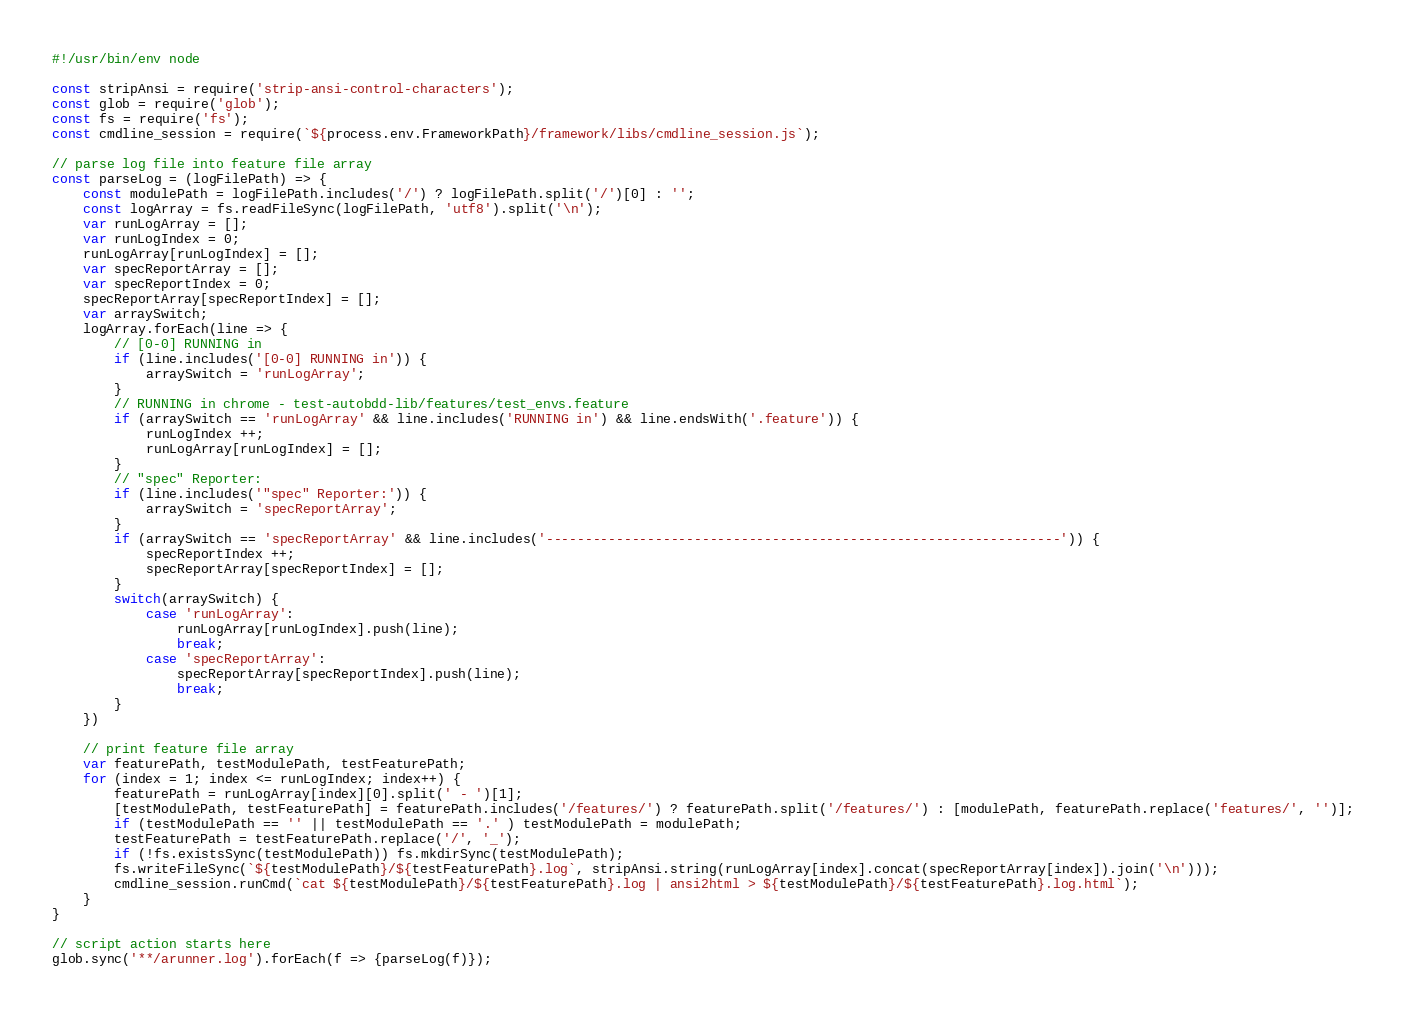Convert code to text. <code><loc_0><loc_0><loc_500><loc_500><_JavaScript_>#!/usr/bin/env node

const stripAnsi = require('strip-ansi-control-characters');
const glob = require('glob');
const fs = require('fs');
const cmdline_session = require(`${process.env.FrameworkPath}/framework/libs/cmdline_session.js`);

// parse log file into feature file array
const parseLog = (logFilePath) => {
    const modulePath = logFilePath.includes('/') ? logFilePath.split('/')[0] : '';
    const logArray = fs.readFileSync(logFilePath, 'utf8').split('\n');
    var runLogArray = [];
    var runLogIndex = 0;
    runLogArray[runLogIndex] = [];
    var specReportArray = [];
    var specReportIndex = 0;
    specReportArray[specReportIndex] = [];
    var arraySwitch;
    logArray.forEach(line => {
        // [0-0] RUNNING in
        if (line.includes('[0-0] RUNNING in')) {
            arraySwitch = 'runLogArray';
        }
        // RUNNING in chrome - test-autobdd-lib/features/test_envs.feature
        if (arraySwitch == 'runLogArray' && line.includes('RUNNING in') && line.endsWith('.feature')) {
            runLogIndex ++;
            runLogArray[runLogIndex] = [];
        }
        // "spec" Reporter:
        if (line.includes('"spec" Reporter:')) {
            arraySwitch = 'specReportArray';
        }
        if (arraySwitch == 'specReportArray' && line.includes('------------------------------------------------------------------')) {
            specReportIndex ++;
            specReportArray[specReportIndex] = [];
        }
        switch(arraySwitch) {
            case 'runLogArray':
                runLogArray[runLogIndex].push(line);
                break;
            case 'specReportArray':
                specReportArray[specReportIndex].push(line);
                break;
        }
    })
    
    // print feature file array
    var featurePath, testModulePath, testFeaturePath;
    for (index = 1; index <= runLogIndex; index++) {
        featurePath = runLogArray[index][0].split(' - ')[1];
        [testModulePath, testFeaturePath] = featurePath.includes('/features/') ? featurePath.split('/features/') : [modulePath, featurePath.replace('features/', '')];
        if (testModulePath == '' || testModulePath == '.' ) testModulePath = modulePath;
        testFeaturePath = testFeaturePath.replace('/', '_');
        if (!fs.existsSync(testModulePath)) fs.mkdirSync(testModulePath);
        fs.writeFileSync(`${testModulePath}/${testFeaturePath}.log`, stripAnsi.string(runLogArray[index].concat(specReportArray[index]).join('\n')));
        cmdline_session.runCmd(`cat ${testModulePath}/${testFeaturePath}.log | ansi2html > ${testModulePath}/${testFeaturePath}.log.html`);
    }    
}

// script action starts here
glob.sync('**/arunner.log').forEach(f => {parseLog(f)});</code> 